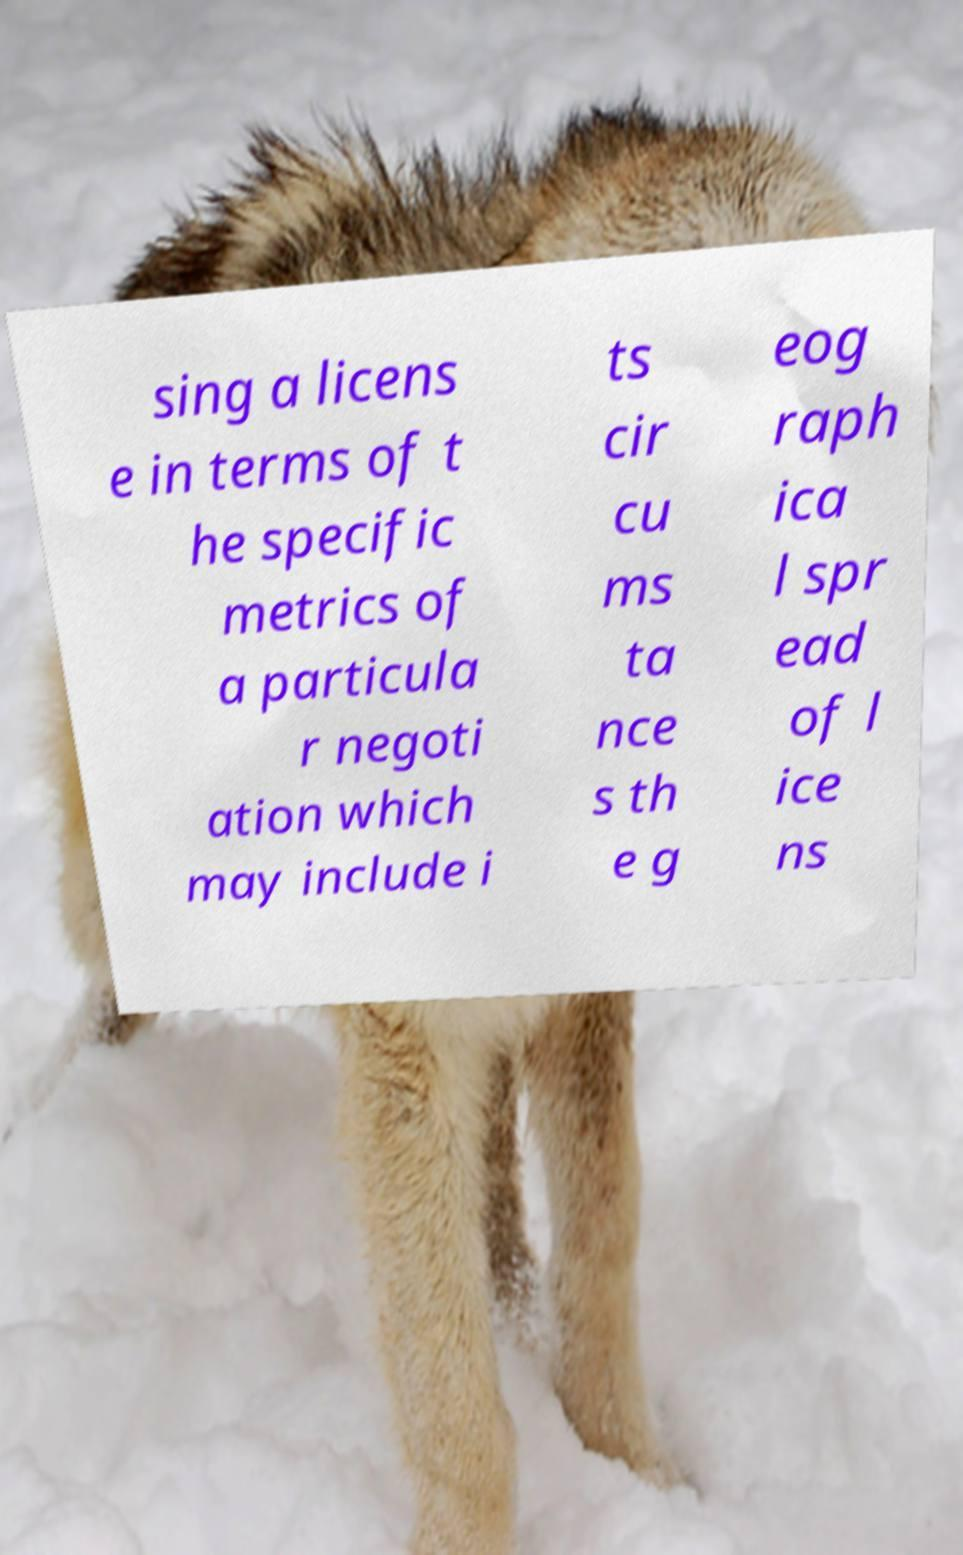What messages or text are displayed in this image? I need them in a readable, typed format. sing a licens e in terms of t he specific metrics of a particula r negoti ation which may include i ts cir cu ms ta nce s th e g eog raph ica l spr ead of l ice ns 